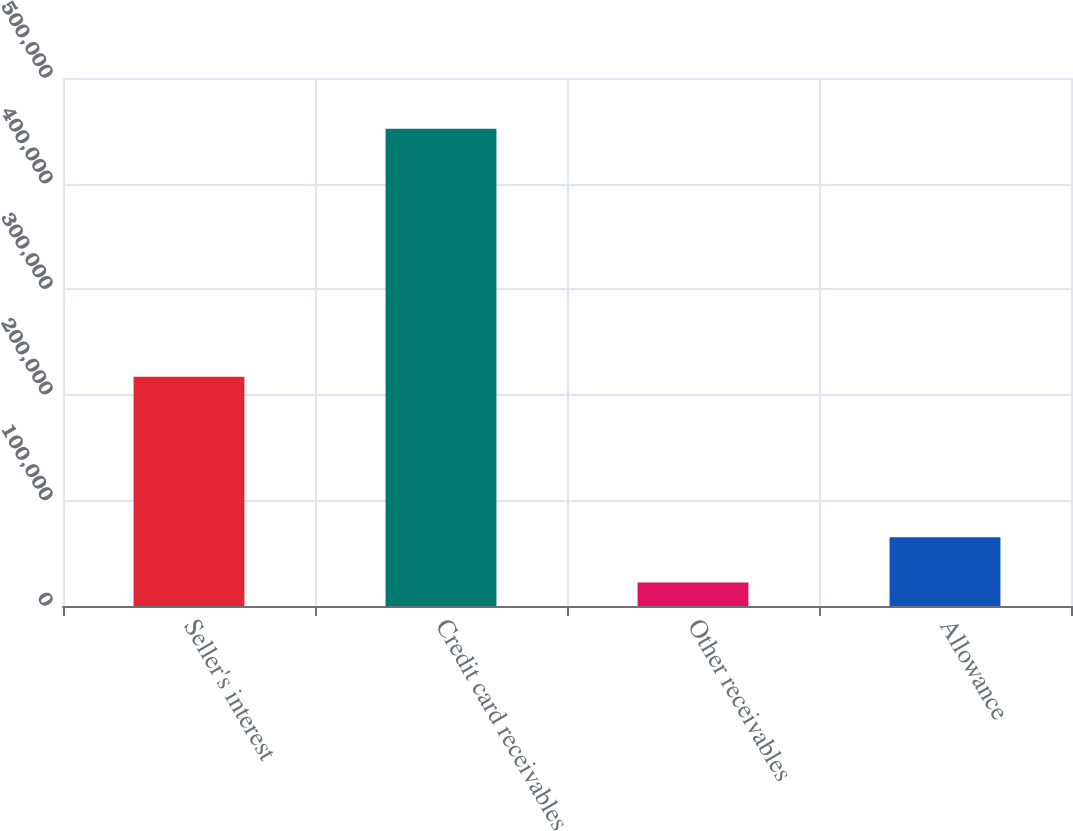<chart> <loc_0><loc_0><loc_500><loc_500><bar_chart><fcel>Seller's interest<fcel>Credit card receivables<fcel>Other receivables<fcel>Allowance<nl><fcel>217054<fcel>451862<fcel>22244<fcel>65205.8<nl></chart> 